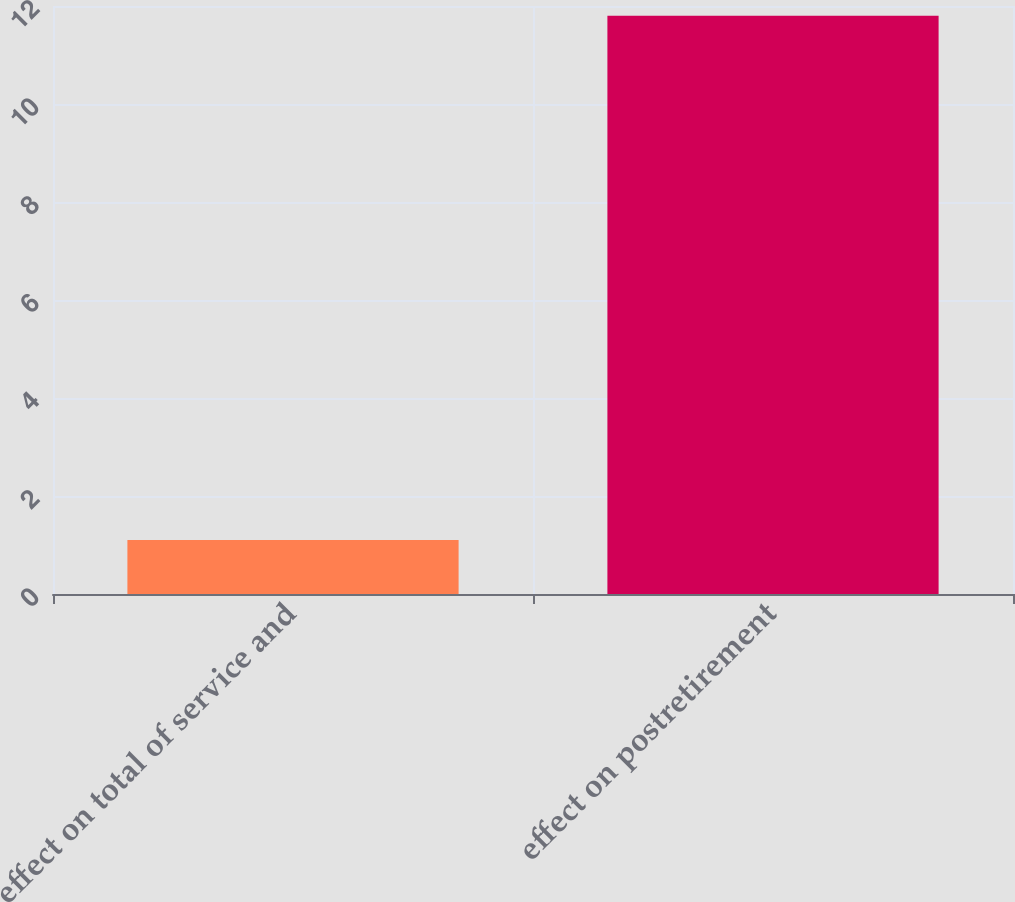Convert chart to OTSL. <chart><loc_0><loc_0><loc_500><loc_500><bar_chart><fcel>effect on total of service and<fcel>effect on postretirement<nl><fcel>1.1<fcel>11.8<nl></chart> 